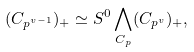<formula> <loc_0><loc_0><loc_500><loc_500>( C _ { p ^ { v - 1 } } ) _ { + } \simeq S ^ { 0 } \bigwedge _ { C _ { p } } ( C _ { p ^ { v } } ) _ { + } ,</formula> 